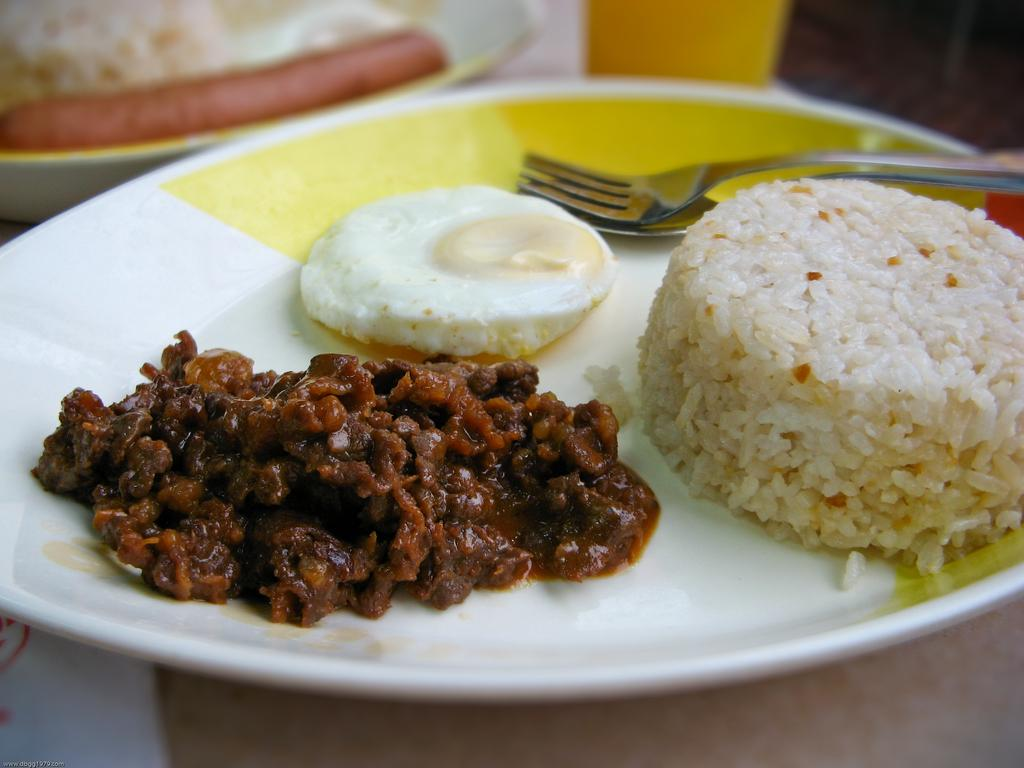How many plates are visible in the image? There are two plates in the image. What is on the plates? The plates contain food items. What utensil is present in the image? There is a fork in the image. What is the glass used for in the image? The glass is used for holding a beverage. Where are the plates, fork, and glass located? The plates, fork, and glass are placed on a table. What type of honey is being used to write on the sheet in the image? There is no honey or sheet present in the image. Is there a notebook being used as a coaster for the glass in the image? There is no notebook present in the image. 